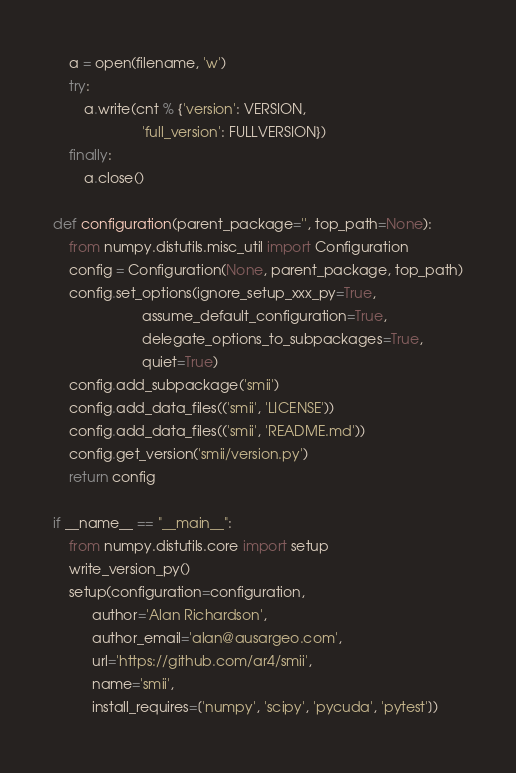Convert code to text. <code><loc_0><loc_0><loc_500><loc_500><_Python_>    a = open(filename, 'w')
    try:
        a.write(cnt % {'version': VERSION,
                       'full_version': FULLVERSION})
    finally:
        a.close()

def configuration(parent_package='', top_path=None):
    from numpy.distutils.misc_util import Configuration
    config = Configuration(None, parent_package, top_path)
    config.set_options(ignore_setup_xxx_py=True,
                       assume_default_configuration=True,
                       delegate_options_to_subpackages=True,
                       quiet=True)
    config.add_subpackage('smii')
    config.add_data_files(('smii', 'LICENSE'))
    config.add_data_files(('smii', 'README.md'))
    config.get_version('smii/version.py')
    return config

if __name__ == "__main__":
    from numpy.distutils.core import setup
    write_version_py()
    setup(configuration=configuration,
          author='Alan Richardson',
          author_email='alan@ausargeo.com',
          url='https://github.com/ar4/smii',
          name='smii',
          install_requires=['numpy', 'scipy', 'pycuda', 'pytest'])
</code> 